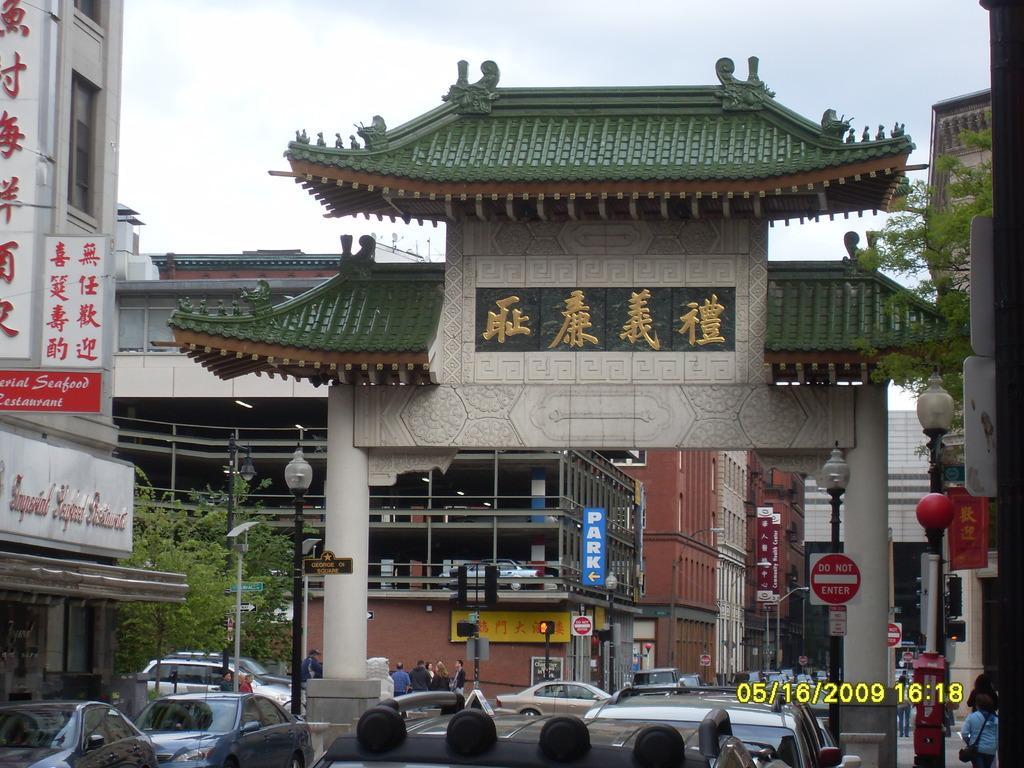Could you give a brief overview of what you see in this image? In this image I can see few vehicles, background I can see few light poles, a traffic signal, few banners and buildings in cream and brown color and the sky is in white color. I can also see trees in green color. 